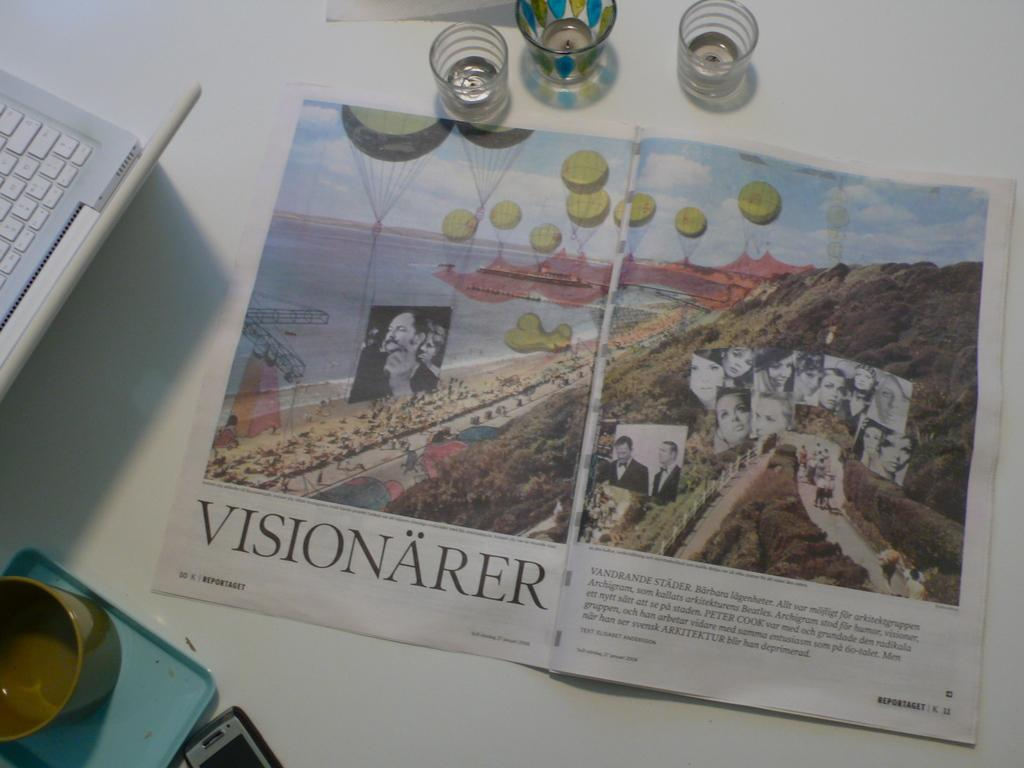What is placed on the white surface in the image? There is a paper, glasses, a mobile, and a laptop on the white surface. Can you describe any other objects on the white surface? Yes, there are other objects on the white surface. What type of device is visible on the white surface? There is a laptop on the white surface. What might be used for communication or entertainment on the white surface? The mobile on the white surface might be used for communication or entertainment. What type of metal can be seen in the image? There is no metal present in the image. Are there any fairies visible in the image? There are no fairies present in the image. 